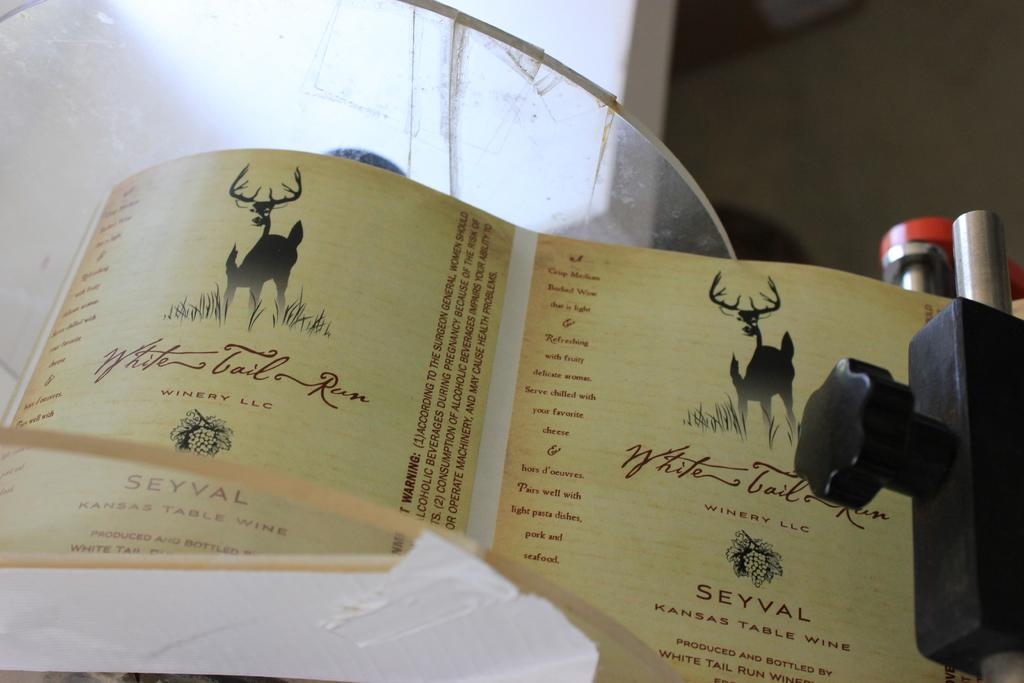<image>
Offer a succinct explanation of the picture presented. a wrapper for a wine bottle called Seyval 